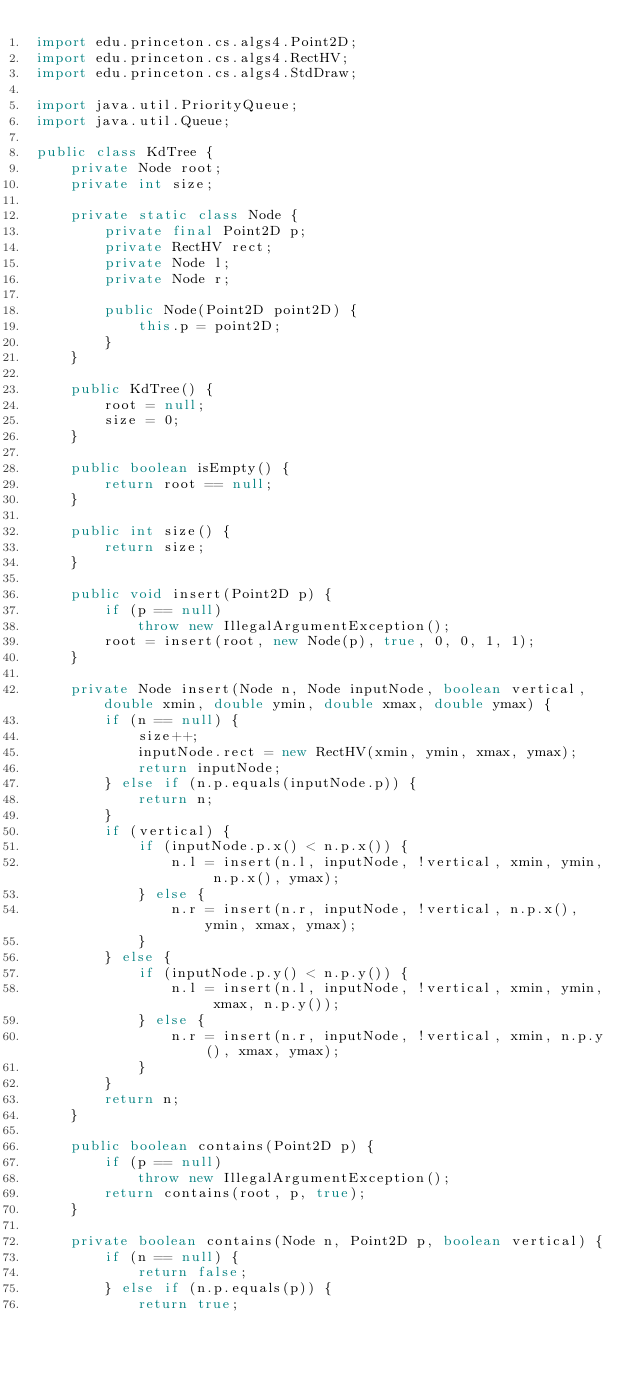Convert code to text. <code><loc_0><loc_0><loc_500><loc_500><_Java_>import edu.princeton.cs.algs4.Point2D;
import edu.princeton.cs.algs4.RectHV;
import edu.princeton.cs.algs4.StdDraw;

import java.util.PriorityQueue;
import java.util.Queue;

public class KdTree {
    private Node root;
    private int size;

    private static class Node {
        private final Point2D p;
        private RectHV rect;
        private Node l;
        private Node r;

        public Node(Point2D point2D) {
            this.p = point2D;
        }
    }

    public KdTree() {
        root = null;
        size = 0;
    }

    public boolean isEmpty() {
        return root == null;
    }

    public int size() {
        return size;
    }

    public void insert(Point2D p) {
        if (p == null)
            throw new IllegalArgumentException();
        root = insert(root, new Node(p), true, 0, 0, 1, 1);
    }

    private Node insert(Node n, Node inputNode, boolean vertical, double xmin, double ymin, double xmax, double ymax) {
        if (n == null) {
            size++;
            inputNode.rect = new RectHV(xmin, ymin, xmax, ymax);
            return inputNode;
        } else if (n.p.equals(inputNode.p)) {
            return n;
        }
        if (vertical) {
            if (inputNode.p.x() < n.p.x()) {
                n.l = insert(n.l, inputNode, !vertical, xmin, ymin, n.p.x(), ymax);
            } else {
                n.r = insert(n.r, inputNode, !vertical, n.p.x(), ymin, xmax, ymax);
            }
        } else {
            if (inputNode.p.y() < n.p.y()) {
                n.l = insert(n.l, inputNode, !vertical, xmin, ymin, xmax, n.p.y());
            } else {
                n.r = insert(n.r, inputNode, !vertical, xmin, n.p.y(), xmax, ymax);
            }
        }
        return n;
    }

    public boolean contains(Point2D p) {
        if (p == null)
            throw new IllegalArgumentException();
        return contains(root, p, true);
    }

    private boolean contains(Node n, Point2D p, boolean vertical) {
        if (n == null) {
            return false;
        } else if (n.p.equals(p)) {
            return true;</code> 